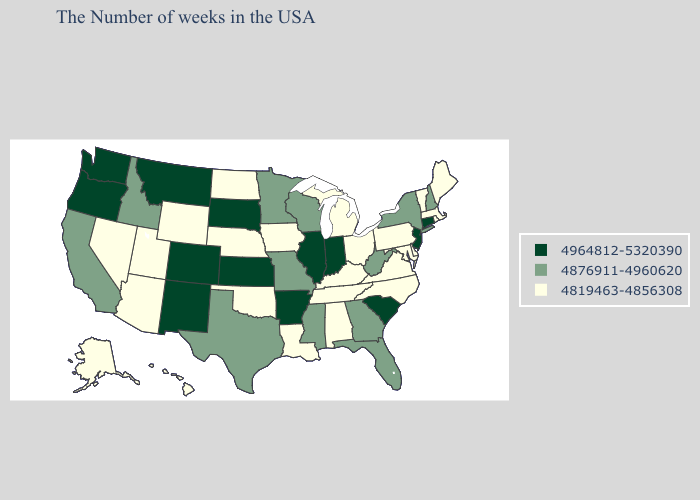How many symbols are there in the legend?
Give a very brief answer. 3. Which states have the highest value in the USA?
Quick response, please. Connecticut, New Jersey, South Carolina, Indiana, Illinois, Arkansas, Kansas, South Dakota, Colorado, New Mexico, Montana, Washington, Oregon. What is the highest value in the MidWest ?
Concise answer only. 4964812-5320390. What is the value of New Mexico?
Concise answer only. 4964812-5320390. Does Illinois have the lowest value in the MidWest?
Be succinct. No. Among the states that border Illinois , which have the lowest value?
Quick response, please. Kentucky, Iowa. Which states hav the highest value in the MidWest?
Write a very short answer. Indiana, Illinois, Kansas, South Dakota. What is the value of Georgia?
Concise answer only. 4876911-4960620. What is the value of Michigan?
Be succinct. 4819463-4856308. Which states have the lowest value in the MidWest?
Concise answer only. Ohio, Michigan, Iowa, Nebraska, North Dakota. Among the states that border West Virginia , which have the lowest value?
Write a very short answer. Maryland, Pennsylvania, Virginia, Ohio, Kentucky. Name the states that have a value in the range 4876911-4960620?
Concise answer only. New Hampshire, New York, West Virginia, Florida, Georgia, Wisconsin, Mississippi, Missouri, Minnesota, Texas, Idaho, California. What is the value of Michigan?
Answer briefly. 4819463-4856308. Among the states that border Missouri , which have the highest value?
Concise answer only. Illinois, Arkansas, Kansas. 